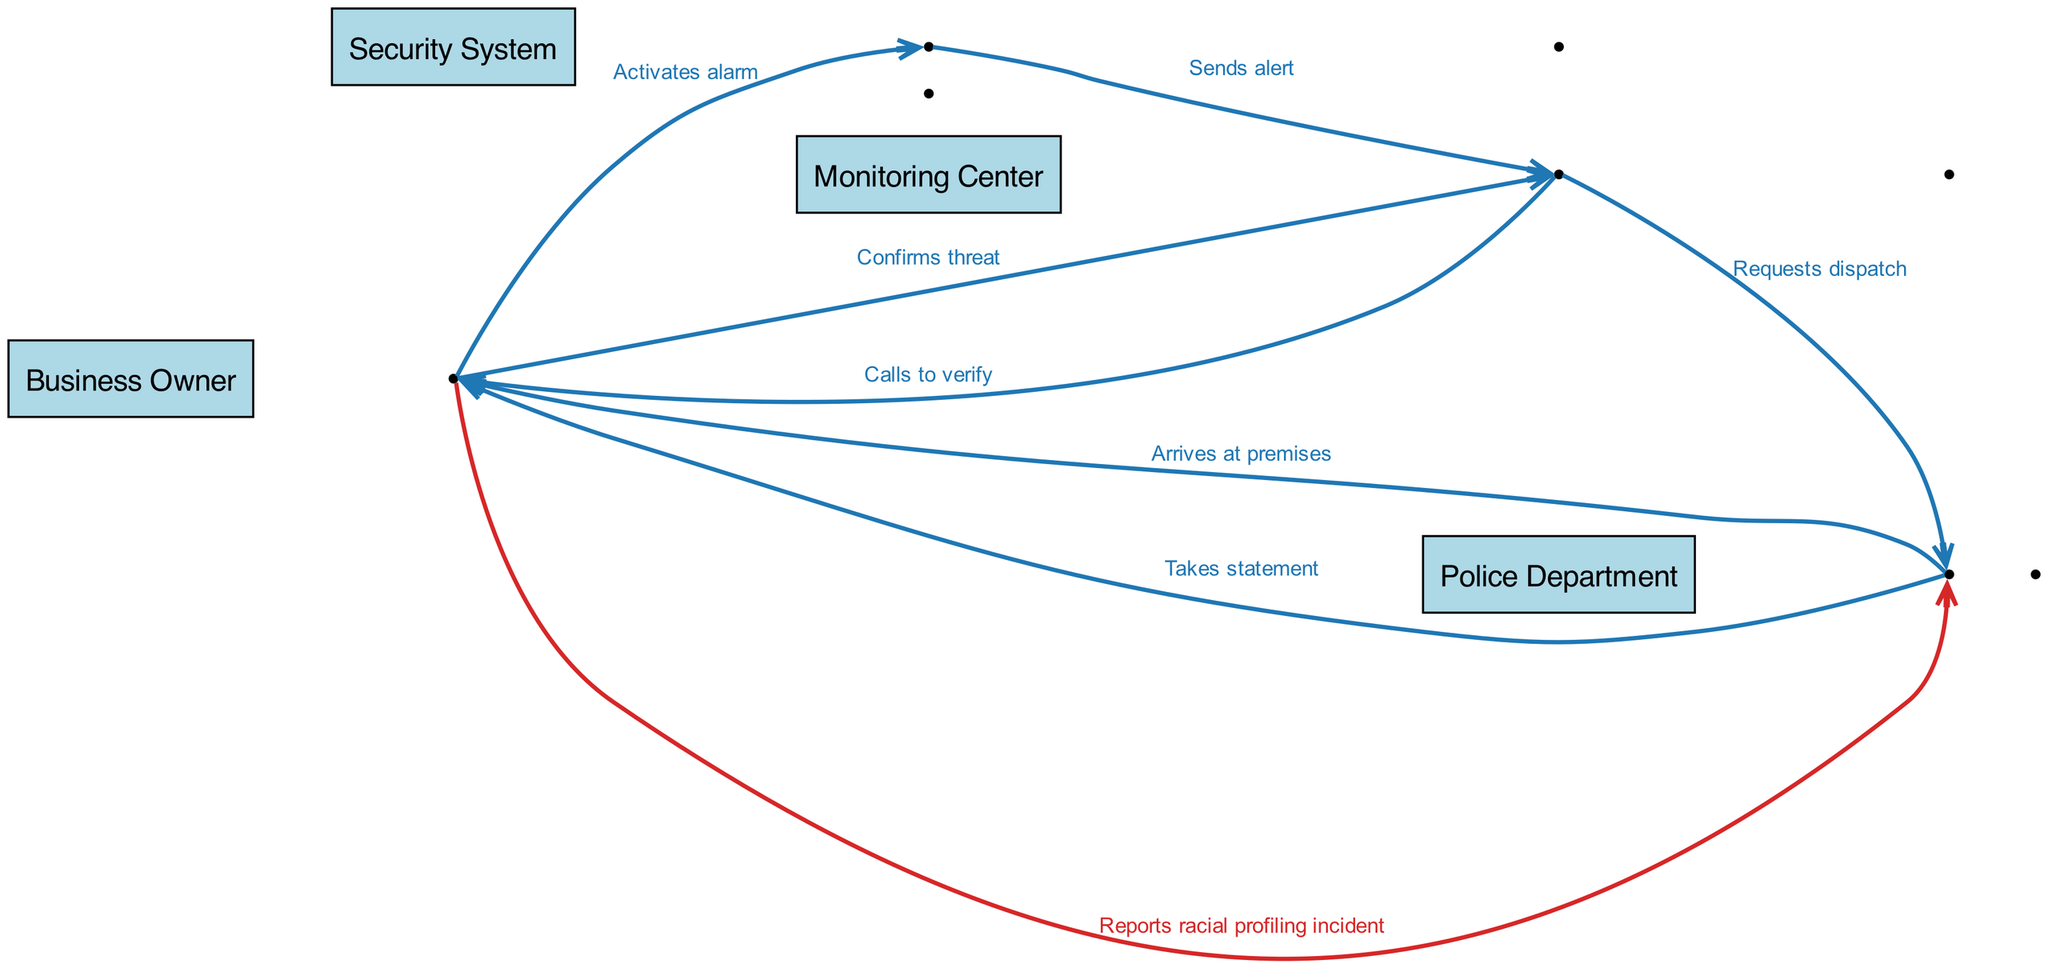What action does the Business Owner take first? The first action from the Business Owner in the sequence is "Activates alarm", which initiates the entire process.
Answer: Activates alarm How many total actors are present in the diagram? The diagram lists four distinct actors: Business Owner, Security System, Monitoring Center, and Police Department. Thus, the total number of actors is four.
Answer: 4 What does the Monitoring Center do after receiving the alert? After receiving the alert from the Security System, the Monitoring Center proceeds to "Calls to verify" with the Business Owner, confirming the situation.
Answer: Calls to verify What color represents the racial profiling incidents in the sequence? The edges associated with actions related to racial profiling incidents are depicted in red (#d62728) to emphasize their importance.
Answer: Red Who does the Monitoring Center request dispatch from? The Monitoring Center sends a request to the Police Department for dispatch after confirming the threat with the Business Owner.
Answer: Police Department What is the last action performed by the Police Department in the sequence? The final action performed by the Police Department in the sequence is "Takes statement" from the Business Owner regarding the incident.
Answer: Takes statement What action does the Business Owner take after the Police Department arrives? Once the Police Department arrives at the premises, the Business Owner proceeds to "Reports racial profiling incident" to ensure the incident is documented.
Answer: Reports racial profiling incident 